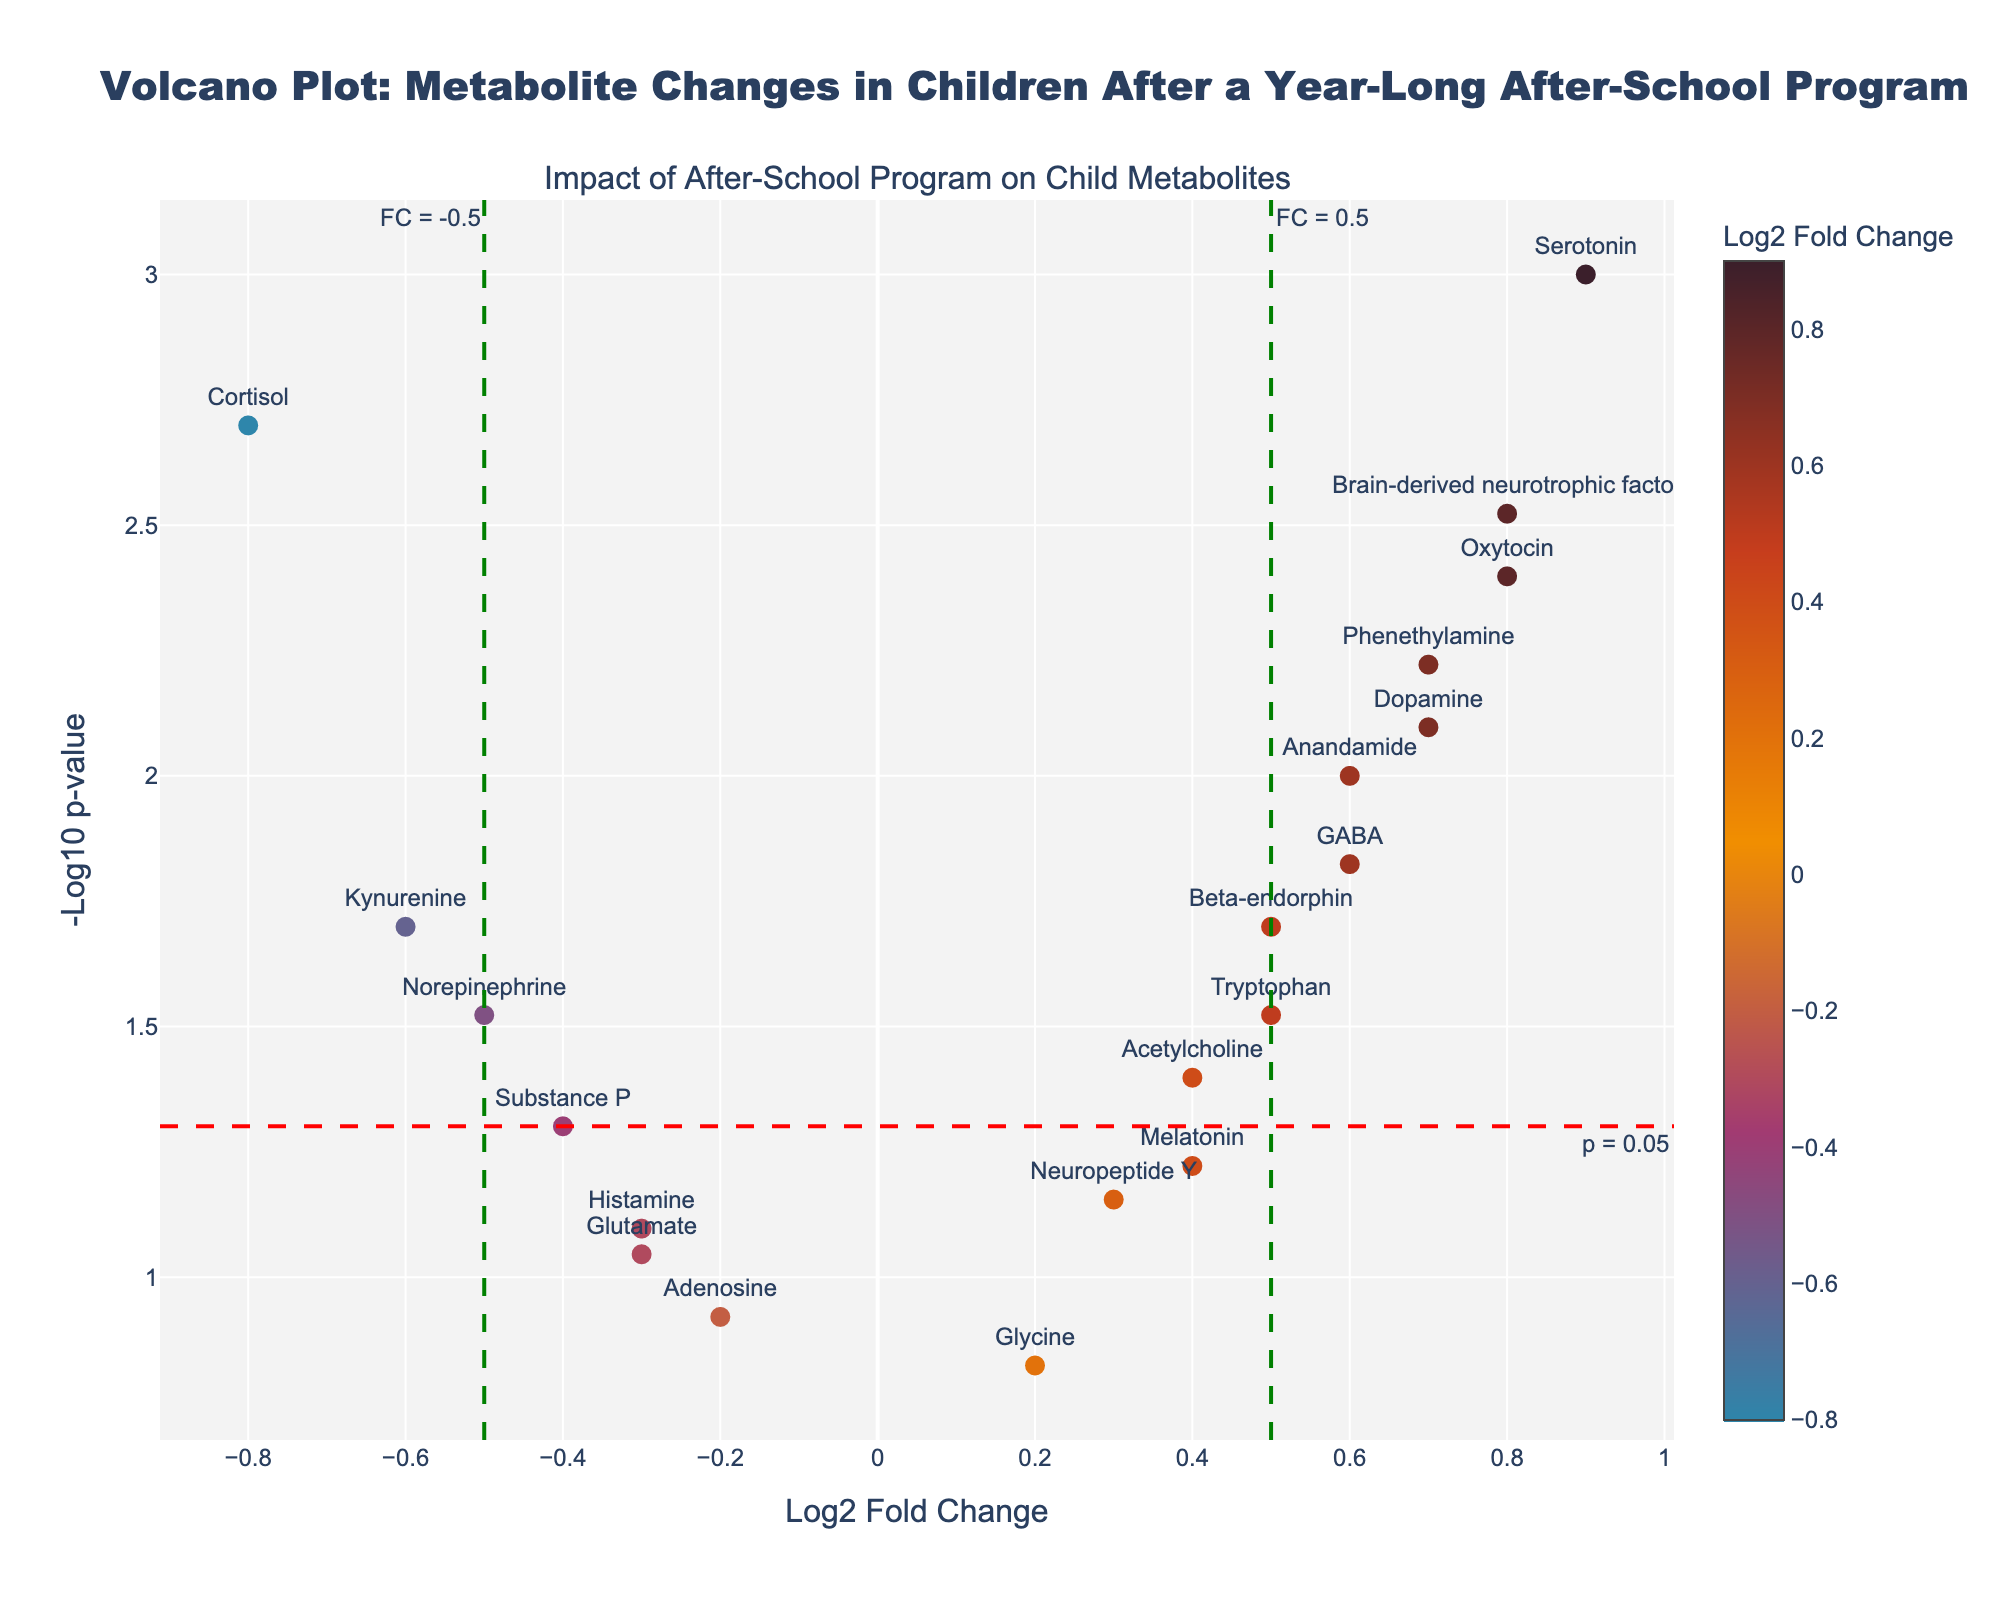What is the title of the figure? The title of the figure can be found at the top of the plot.
Answer: Volcano Plot: Metabolite Changes in Children After a Year-Long After-School Program How many metabolites have a positive log2 fold change? To determine this, count the points on the right side of the y-axis (where log2 fold change is positive).
Answer: 10 Which metabolite has the highest -log10 p-value? Look for the metabolite with the highest position along the y-axis.
Answer: Serotonin Are there any metabolites with a p-value above 0.05 and log2 fold change of greater than 0.5? Check points above y=-log10(0.05) (1.301) and to the right of x=0.5.
Answer: No What does the red dashed horizontal line represent? The plot notes that lines represent significance thresholds, with the red line indicating -log10(p-value) for p=0.05.
Answer: p = 0.05 How many metabolites have a -log10 p-value greater than 1.301 (p-value < 0.05)? Count the points above the red dashed horizontal line at y=-log10(0.05).
Answer: 11 Which metabolites are most significantly increased after the program? Look for metabolites with high positive log2 fold change and low p-values (high y-axis values).
Answer: Serotonin, Oxytocin, GABA, Brain-derived neurotrophic factor Which metabolite shows the greatest decrease after the program? Identify the point on the leftmost side (most negative log2 fold change).
Answer: Cortisol Do any metabolites show a significant negative change after the program? Check for metabolites with a log2 fold change less than -0.5 and a p-value less than 0.05.
Answer: Cortisol, Kynurenine Compare the log2 fold change of Dopamine and Beta-endorphin. Which one increased more? Find the log2 fold change of both metabolites and compare their x-coordinates.
Answer: Dopamine 